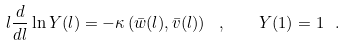<formula> <loc_0><loc_0><loc_500><loc_500>l \frac { d } { d l } \ln Y ( l ) = - \kappa \left ( \bar { w } ( l ) , \bar { v } ( l ) \right ) \ , \quad Y ( 1 ) = 1 \ .</formula> 